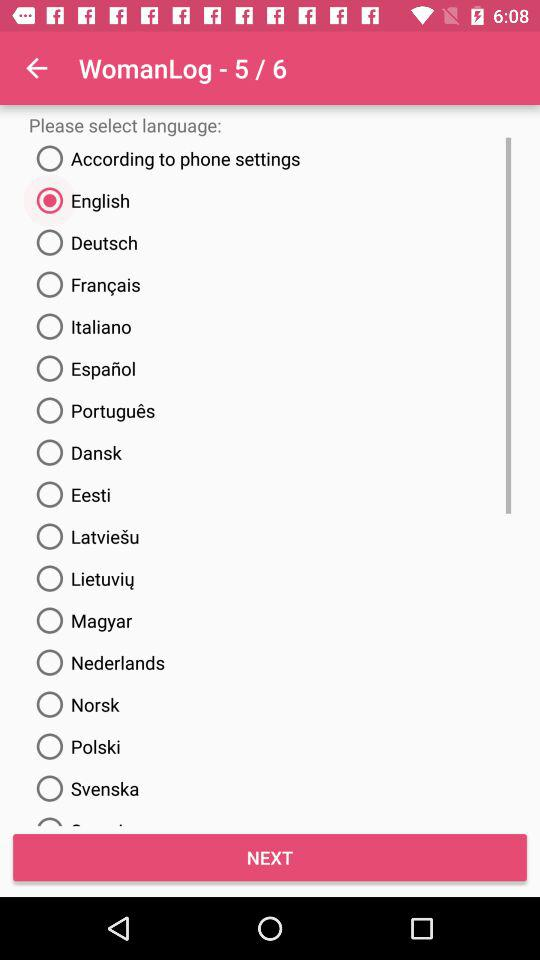How many total "WomanLog" are there? There are 6 "WomanLog" in total. 